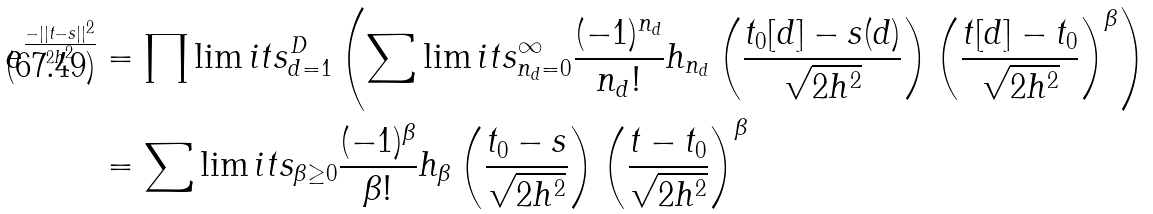<formula> <loc_0><loc_0><loc_500><loc_500>e ^ { \frac { - | | t - s | | ^ { 2 } } { 2 h ^ { 2 } } } & = \prod \lim i t s _ { d = 1 } ^ { D } \left ( \sum \lim i t s _ { n _ { d } = 0 } ^ { \infty } \frac { ( - 1 ) ^ { n _ { d } } } { n _ { d } ! } h _ { n _ { d } } \left ( \frac { t _ { 0 } [ d ] - s ( d ) } { \sqrt { 2 h ^ { 2 } } } \right ) \left ( \frac { t [ d ] - t _ { 0 } } { \sqrt { 2 h ^ { 2 } } } \right ) ^ { \beta } \right ) \\ & = \sum \lim i t s _ { \beta \geq 0 } \frac { ( - 1 ) ^ { \beta } } { \beta ! } h _ { \beta } \left ( \frac { t _ { 0 } - s } { \sqrt { 2 h ^ { 2 } } } \right ) \left ( \frac { t - t _ { 0 } } { \sqrt { 2 h ^ { 2 } } } \right ) ^ { \beta }</formula> 